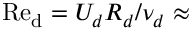<formula> <loc_0><loc_0><loc_500><loc_500>R e _ { d } = U _ { d } R _ { d } / \nu _ { d } \approx</formula> 